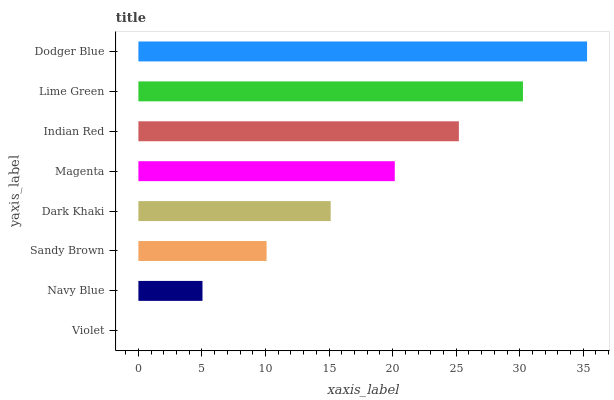Is Violet the minimum?
Answer yes or no. Yes. Is Dodger Blue the maximum?
Answer yes or no. Yes. Is Navy Blue the minimum?
Answer yes or no. No. Is Navy Blue the maximum?
Answer yes or no. No. Is Navy Blue greater than Violet?
Answer yes or no. Yes. Is Violet less than Navy Blue?
Answer yes or no. Yes. Is Violet greater than Navy Blue?
Answer yes or no. No. Is Navy Blue less than Violet?
Answer yes or no. No. Is Magenta the high median?
Answer yes or no. Yes. Is Dark Khaki the low median?
Answer yes or no. Yes. Is Dark Khaki the high median?
Answer yes or no. No. Is Magenta the low median?
Answer yes or no. No. 